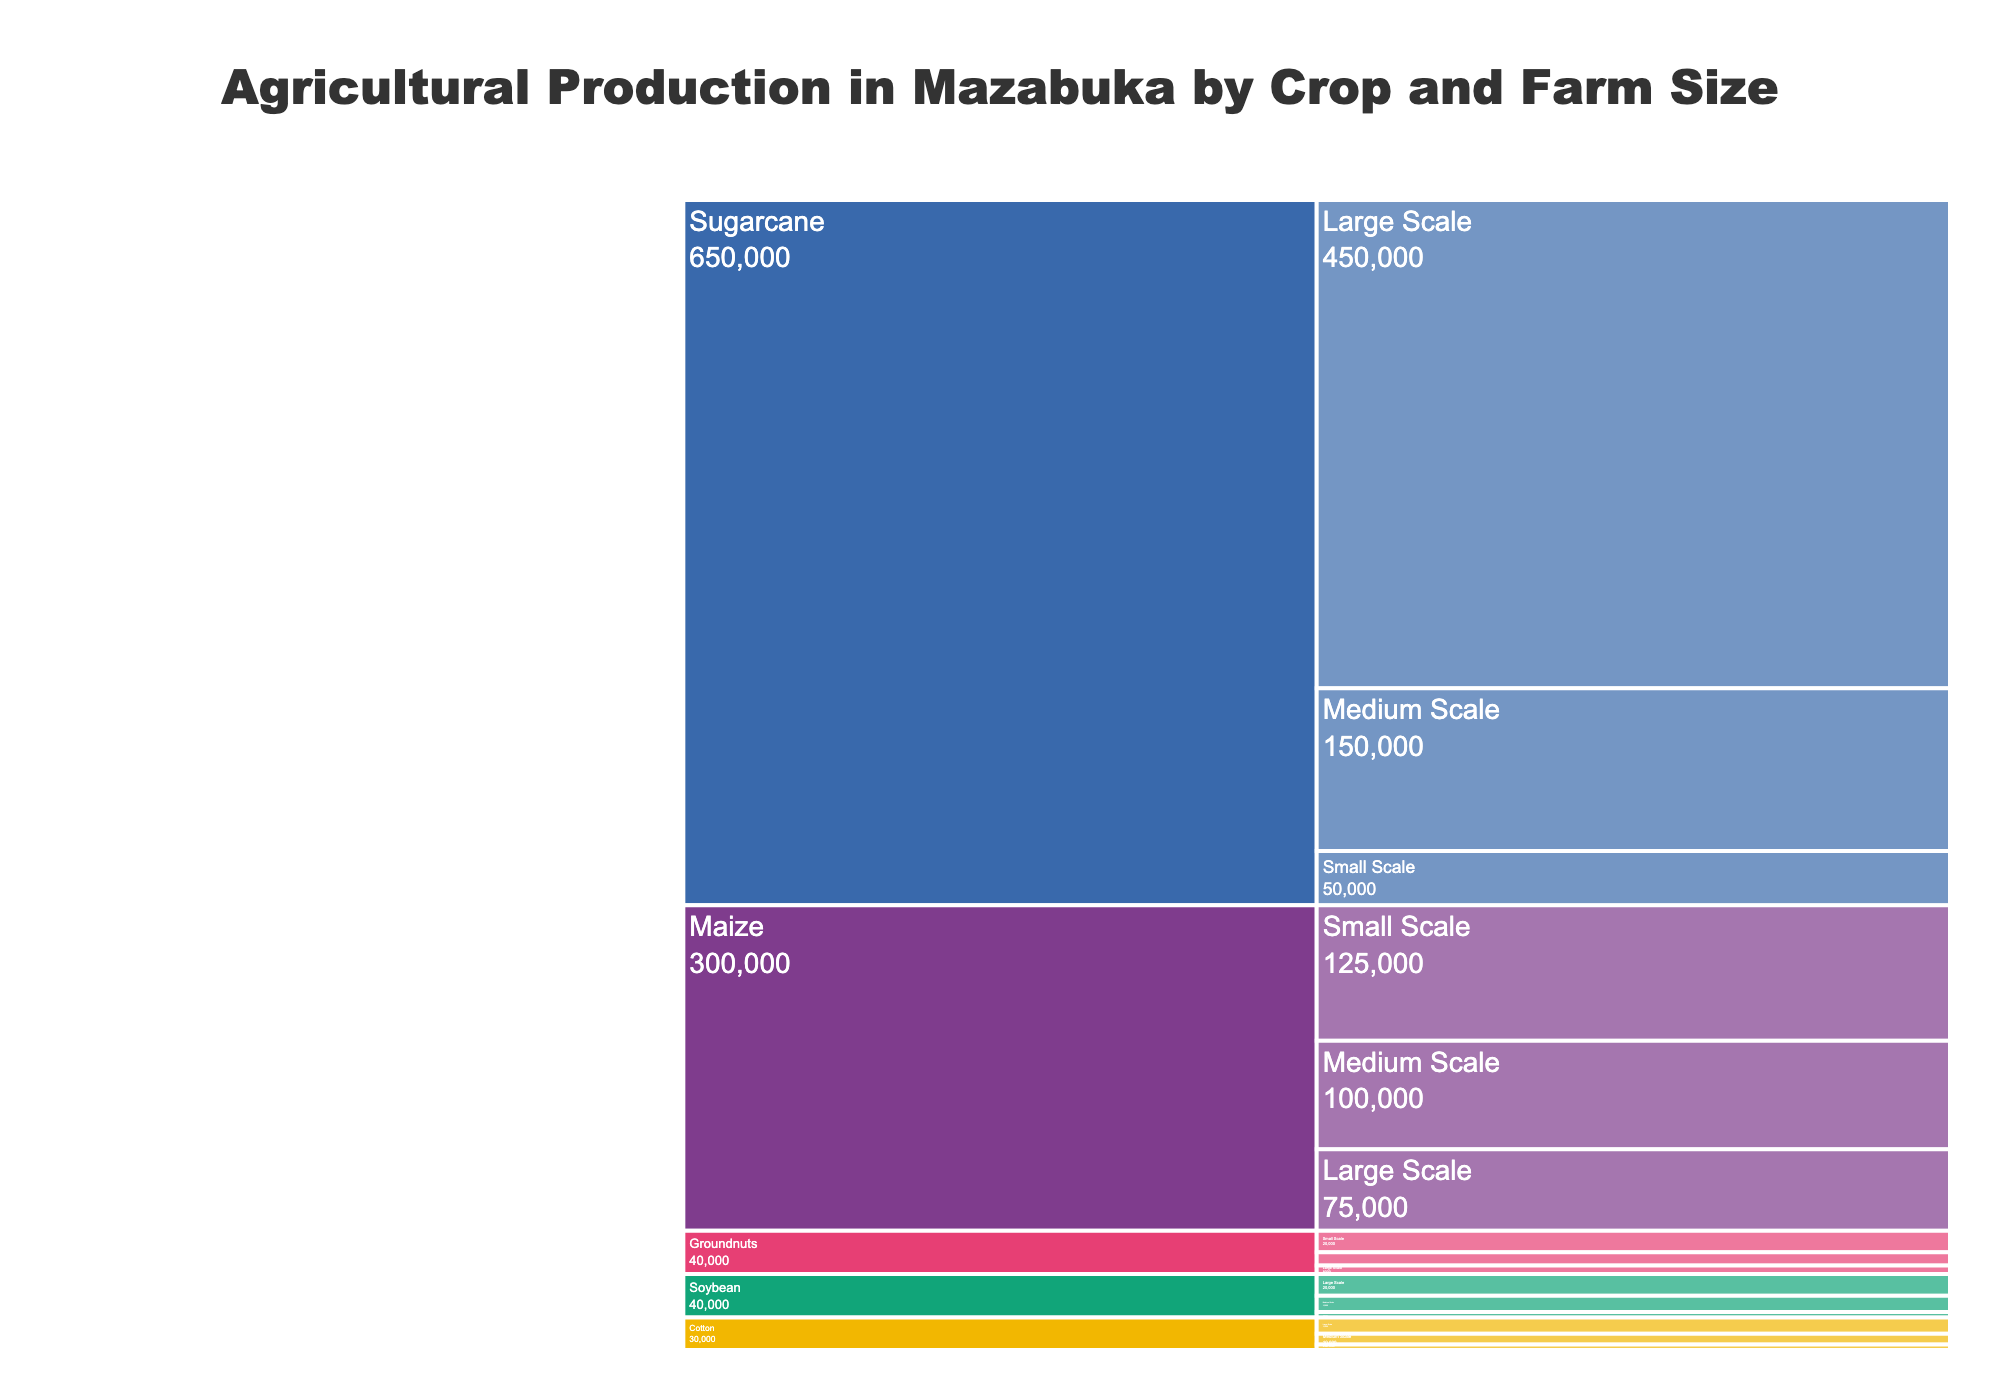What is the title of the chart? The title is usually located at the top of the chart and provides a concise summary of what the figure represents.
Answer: Agricultural Production in Mazabuka by Crop and Farm Size How many crop types are included in the chart? The chart has distinct sections for each crop type, indicated by unique colors and labels.
Answer: Five Which crop has the highest total production? To find which crop has the highest total production, sum up the production values for each farm size for every crop, then compare the totals. Sugarcane has the highest total production (450,000 + 150,000 + 50,000 = 650,000 tons).
Answer: Sugarcane What is the production on medium-scale farms for maize? Locate the maize section, then find the medium-scale farm subdivision within it. The production value will be provided there.
Answer: 100,000 tons Which farm size category contributes the most to maize production? Sum up the production values for all farm sizes (large, medium, and small) under maize and compare them. The small-scale farm size has the highest production (125,000 tons).
Answer: Small Scale How does the production of groundnuts on small-scale farms compare to that on medium-scale farms? Look at the groundnuts section and find the production values for small and medium-scale farms. Compare both values. Small-scale production (20,000 tons) is higher than medium-scale production (12,000 tons).
Answer: Small-scale production is higher What is the total agricultural output for all crops combined? Sum the production values for all crops and farm sizes. Total output = Sugarcane (650,000) + Maize (300,000) + Soybeans (40,000) + Groundnuts (40,000) + Cotton (30,000) = 1,060,000 tons.
Answer: 1,060,000 tons Compare the soybean production on large and medium-scale farms. Which is greater and by how much? Navigate to the soybean section and compare the production values of large-scale farms (20,000 tons) to medium-scale farms (15,000 tons). Calculate the difference: 20,000 - 15,000 = 5,000 tons.
Answer: Large-scale by 5,000 tons What percentage of the total maize production comes from small-scale farms? Calculate the percentage by dividing the small-scale maize production by the total maize production, then multiply by 100. (125,000 / 300,000) * 100 = 41.67%.
Answer: 41.67% Which crop has the smallest production on large-scale farms? Compare the production values in the large-scale farm sections of the chart. Groundnuts have the smallest production at 8,000 tons.
Answer: Groundnuts 